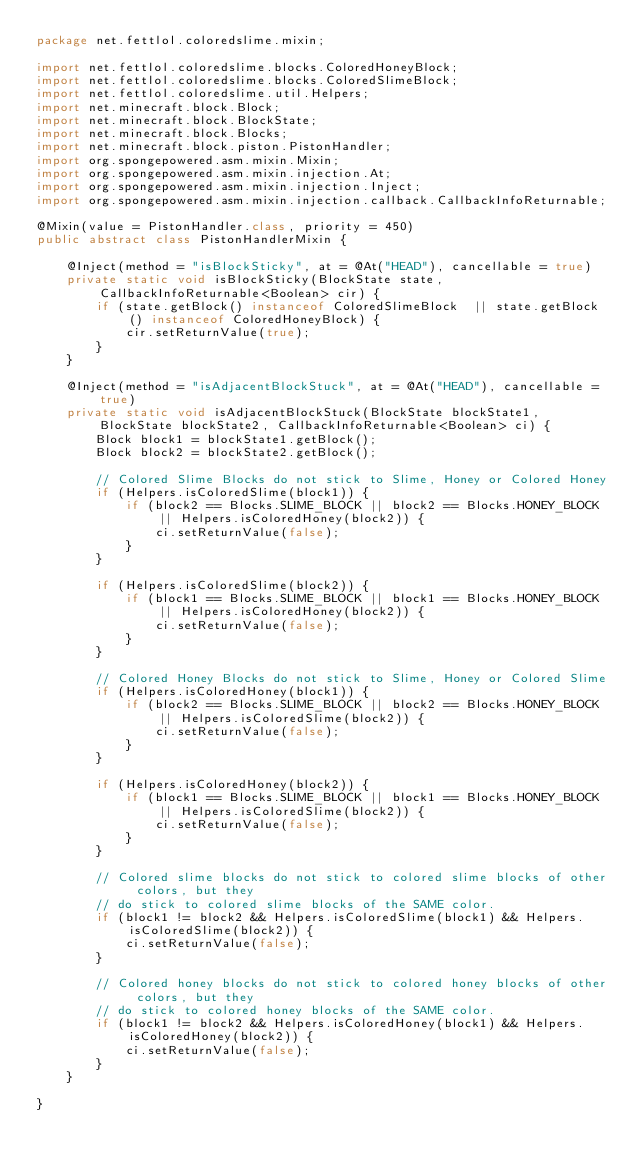Convert code to text. <code><loc_0><loc_0><loc_500><loc_500><_Java_>package net.fettlol.coloredslime.mixin;

import net.fettlol.coloredslime.blocks.ColoredHoneyBlock;
import net.fettlol.coloredslime.blocks.ColoredSlimeBlock;
import net.fettlol.coloredslime.util.Helpers;
import net.minecraft.block.Block;
import net.minecraft.block.BlockState;
import net.minecraft.block.Blocks;
import net.minecraft.block.piston.PistonHandler;
import org.spongepowered.asm.mixin.Mixin;
import org.spongepowered.asm.mixin.injection.At;
import org.spongepowered.asm.mixin.injection.Inject;
import org.spongepowered.asm.mixin.injection.callback.CallbackInfoReturnable;

@Mixin(value = PistonHandler.class, priority = 450)
public abstract class PistonHandlerMixin {

    @Inject(method = "isBlockSticky", at = @At("HEAD"), cancellable = true)
    private static void isBlockSticky(BlockState state, CallbackInfoReturnable<Boolean> cir) {
        if (state.getBlock() instanceof ColoredSlimeBlock  || state.getBlock() instanceof ColoredHoneyBlock) {
            cir.setReturnValue(true);
        }
    }

    @Inject(method = "isAdjacentBlockStuck", at = @At("HEAD"), cancellable = true)
    private static void isAdjacentBlockStuck(BlockState blockState1, BlockState blockState2, CallbackInfoReturnable<Boolean> ci) {
        Block block1 = blockState1.getBlock();
        Block block2 = blockState2.getBlock();

        // Colored Slime Blocks do not stick to Slime, Honey or Colored Honey
        if (Helpers.isColoredSlime(block1)) {
            if (block2 == Blocks.SLIME_BLOCK || block2 == Blocks.HONEY_BLOCK || Helpers.isColoredHoney(block2)) {
                ci.setReturnValue(false);
            }
        }

        if (Helpers.isColoredSlime(block2)) {
            if (block1 == Blocks.SLIME_BLOCK || block1 == Blocks.HONEY_BLOCK || Helpers.isColoredHoney(block2)) {
                ci.setReturnValue(false);
            }
        }

        // Colored Honey Blocks do not stick to Slime, Honey or Colored Slime
        if (Helpers.isColoredHoney(block1)) {
            if (block2 == Blocks.SLIME_BLOCK || block2 == Blocks.HONEY_BLOCK || Helpers.isColoredSlime(block2)) {
                ci.setReturnValue(false);
            }
        }

        if (Helpers.isColoredHoney(block2)) {
            if (block1 == Blocks.SLIME_BLOCK || block1 == Blocks.HONEY_BLOCK || Helpers.isColoredSlime(block2)) {
                ci.setReturnValue(false);
            }
        }

        // Colored slime blocks do not stick to colored slime blocks of other colors, but they
        // do stick to colored slime blocks of the SAME color.
        if (block1 != block2 && Helpers.isColoredSlime(block1) && Helpers.isColoredSlime(block2)) {
            ci.setReturnValue(false);
        }

        // Colored honey blocks do not stick to colored honey blocks of other colors, but they
        // do stick to colored honey blocks of the SAME color.
        if (block1 != block2 && Helpers.isColoredHoney(block1) && Helpers.isColoredHoney(block2)) {
            ci.setReturnValue(false);
        }
    }

}
</code> 